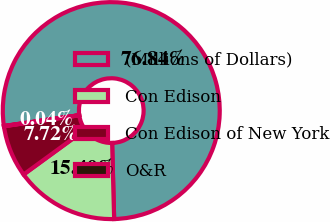Convert chart. <chart><loc_0><loc_0><loc_500><loc_500><pie_chart><fcel>(Millions of Dollars)<fcel>Con Edison<fcel>Con Edison of New York<fcel>O&R<nl><fcel>76.84%<fcel>15.4%<fcel>7.72%<fcel>0.04%<nl></chart> 